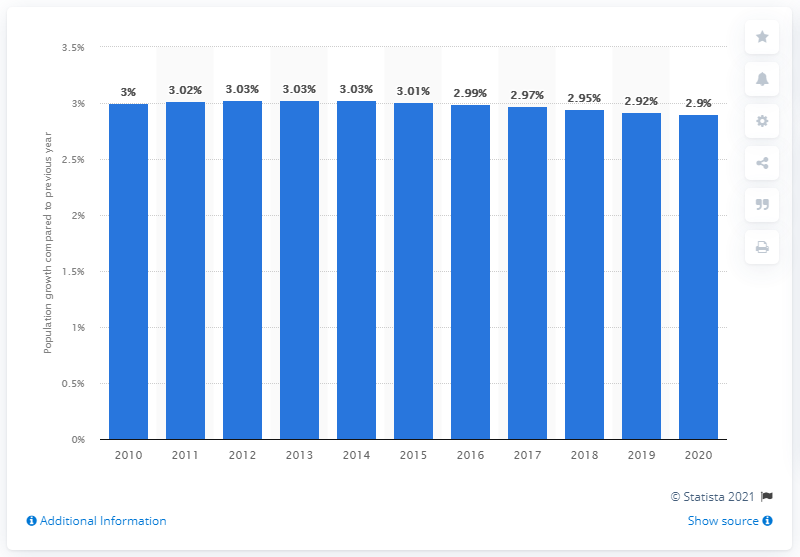Identify some key points in this picture. The population of the Gambia increased by 2.9% in 2020. 